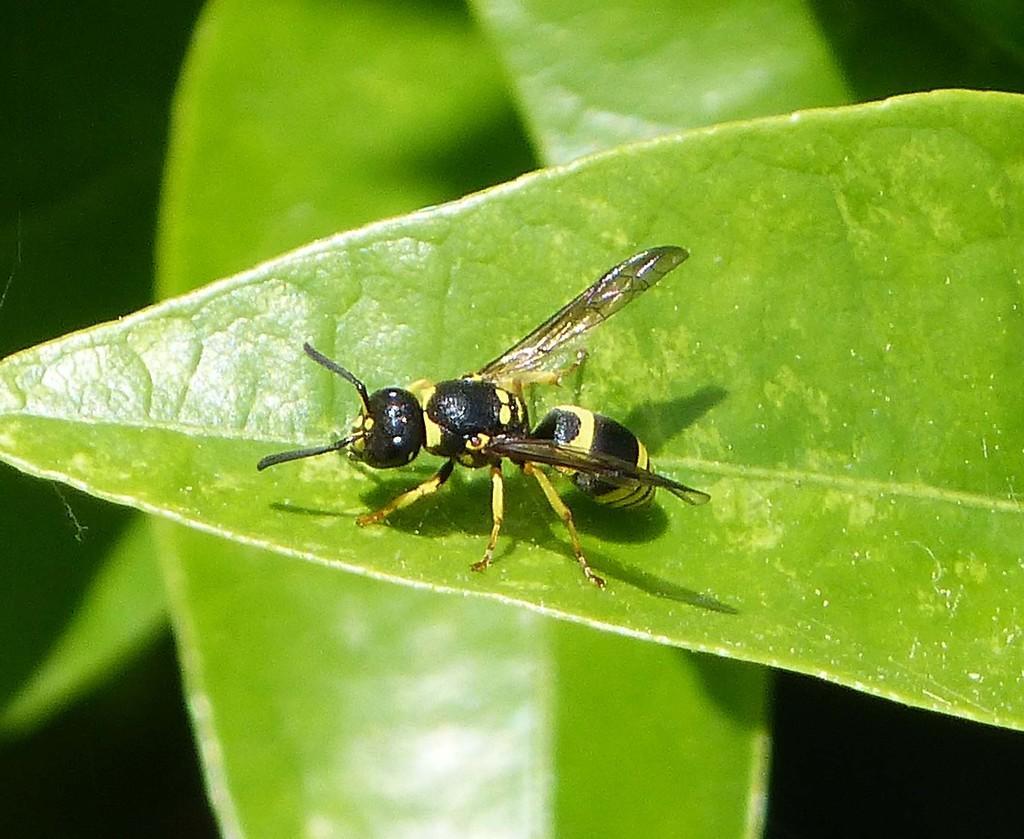How would you summarize this image in a sentence or two? In this image, we can see some leaves. Among them, we can see an insect on one of the leaves. We can also see the background. 